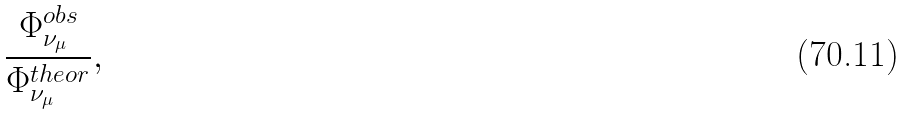Convert formula to latex. <formula><loc_0><loc_0><loc_500><loc_500>\frac { \Phi _ { \nu _ { \mu } } ^ { o b s } } { \Phi _ { \nu _ { \mu } } ^ { t h e o r } } ,</formula> 